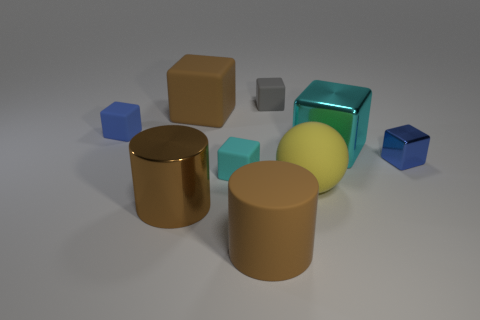Subtract all big brown matte cubes. How many cubes are left? 5 Subtract all cyan blocks. How many blocks are left? 4 Subtract all green cubes. Subtract all red balls. How many cubes are left? 6 Add 1 tiny red matte spheres. How many objects exist? 10 Subtract all balls. How many objects are left? 8 Add 4 gray metal blocks. How many gray metal blocks exist? 4 Subtract 0 purple blocks. How many objects are left? 9 Subtract all large purple cylinders. Subtract all cyan matte things. How many objects are left? 8 Add 8 small blue objects. How many small blue objects are left? 10 